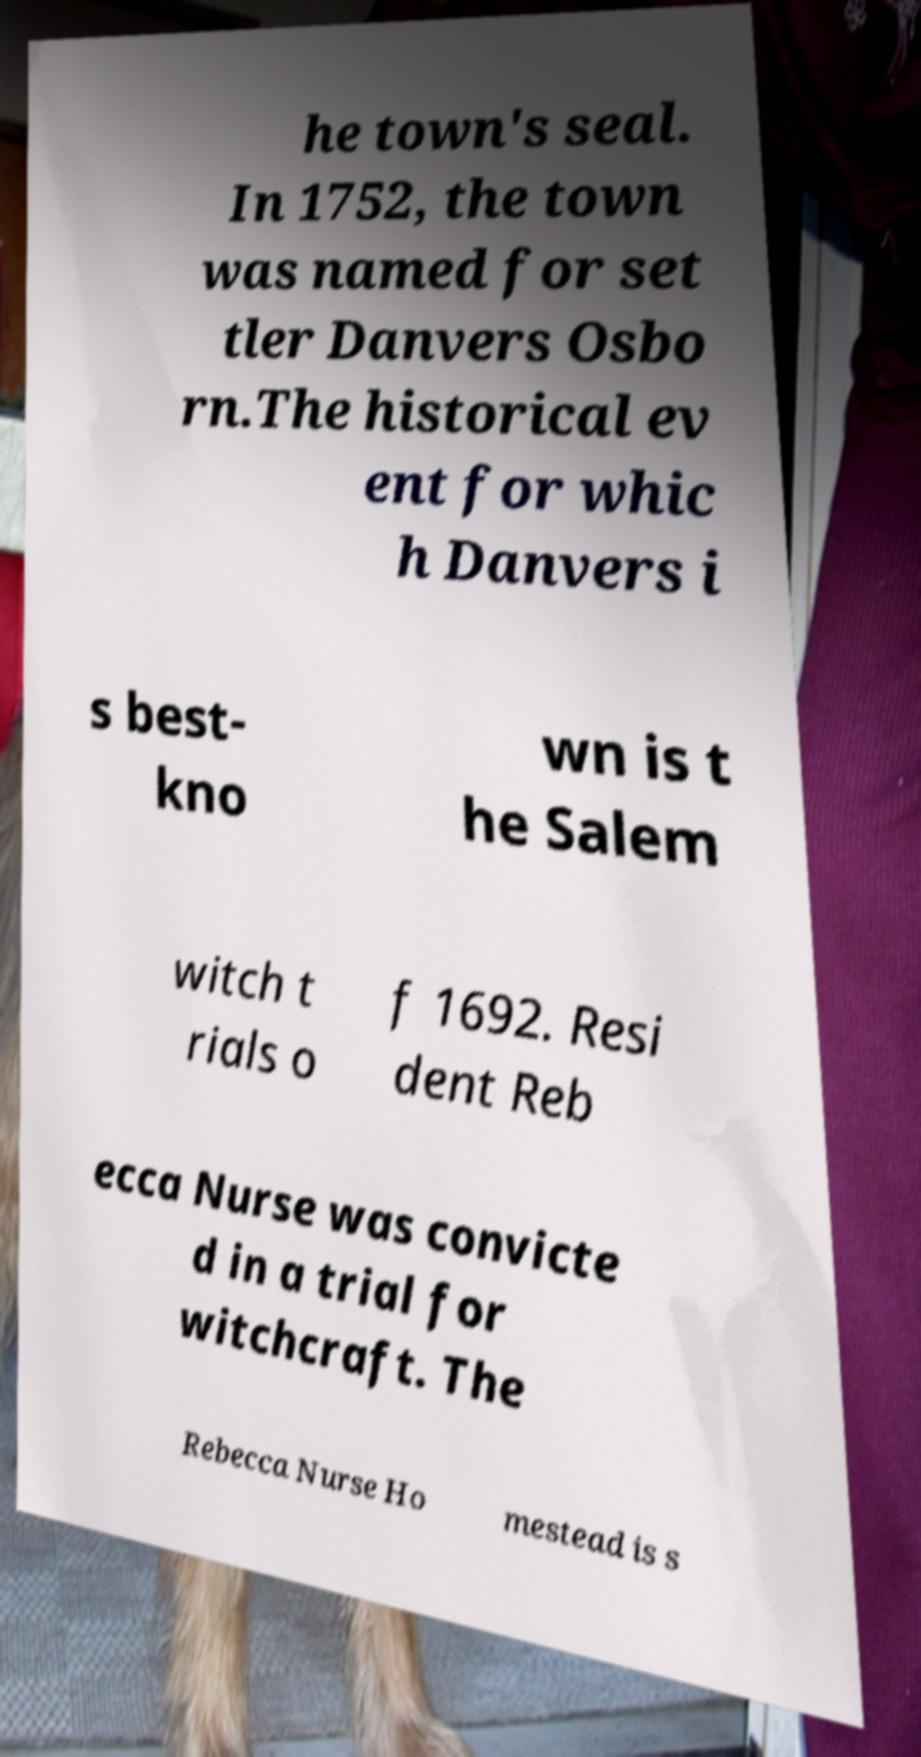Can you read and provide the text displayed in the image?This photo seems to have some interesting text. Can you extract and type it out for me? he town's seal. In 1752, the town was named for set tler Danvers Osbo rn.The historical ev ent for whic h Danvers i s best- kno wn is t he Salem witch t rials o f 1692. Resi dent Reb ecca Nurse was convicte d in a trial for witchcraft. The Rebecca Nurse Ho mestead is s 